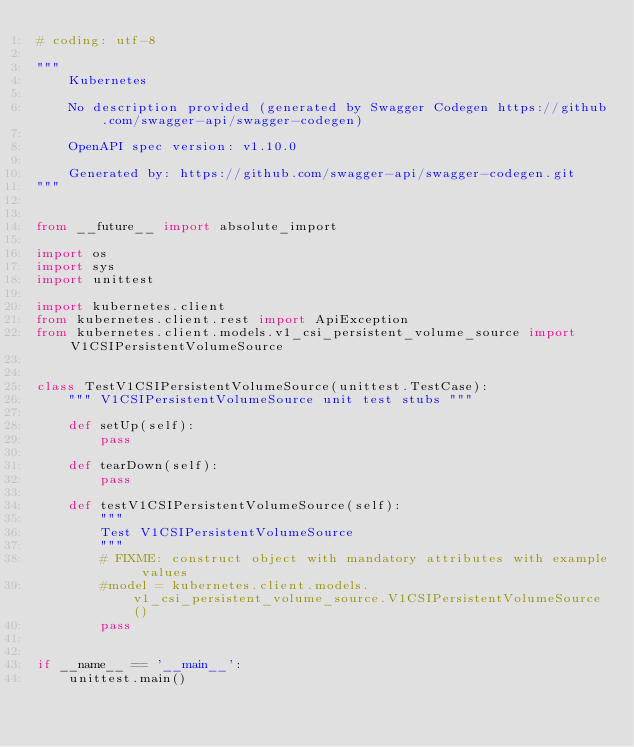Convert code to text. <code><loc_0><loc_0><loc_500><loc_500><_Python_># coding: utf-8

"""
    Kubernetes

    No description provided (generated by Swagger Codegen https://github.com/swagger-api/swagger-codegen)

    OpenAPI spec version: v1.10.0
    
    Generated by: https://github.com/swagger-api/swagger-codegen.git
"""


from __future__ import absolute_import

import os
import sys
import unittest

import kubernetes.client
from kubernetes.client.rest import ApiException
from kubernetes.client.models.v1_csi_persistent_volume_source import V1CSIPersistentVolumeSource


class TestV1CSIPersistentVolumeSource(unittest.TestCase):
    """ V1CSIPersistentVolumeSource unit test stubs """

    def setUp(self):
        pass

    def tearDown(self):
        pass

    def testV1CSIPersistentVolumeSource(self):
        """
        Test V1CSIPersistentVolumeSource
        """
        # FIXME: construct object with mandatory attributes with example values
        #model = kubernetes.client.models.v1_csi_persistent_volume_source.V1CSIPersistentVolumeSource()
        pass


if __name__ == '__main__':
    unittest.main()
</code> 